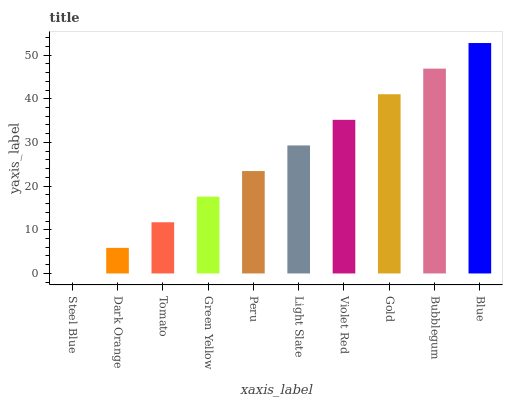Is Steel Blue the minimum?
Answer yes or no. Yes. Is Blue the maximum?
Answer yes or no. Yes. Is Dark Orange the minimum?
Answer yes or no. No. Is Dark Orange the maximum?
Answer yes or no. No. Is Dark Orange greater than Steel Blue?
Answer yes or no. Yes. Is Steel Blue less than Dark Orange?
Answer yes or no. Yes. Is Steel Blue greater than Dark Orange?
Answer yes or no. No. Is Dark Orange less than Steel Blue?
Answer yes or no. No. Is Light Slate the high median?
Answer yes or no. Yes. Is Peru the low median?
Answer yes or no. Yes. Is Peru the high median?
Answer yes or no. No. Is Light Slate the low median?
Answer yes or no. No. 